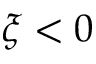Convert formula to latex. <formula><loc_0><loc_0><loc_500><loc_500>\xi < 0</formula> 